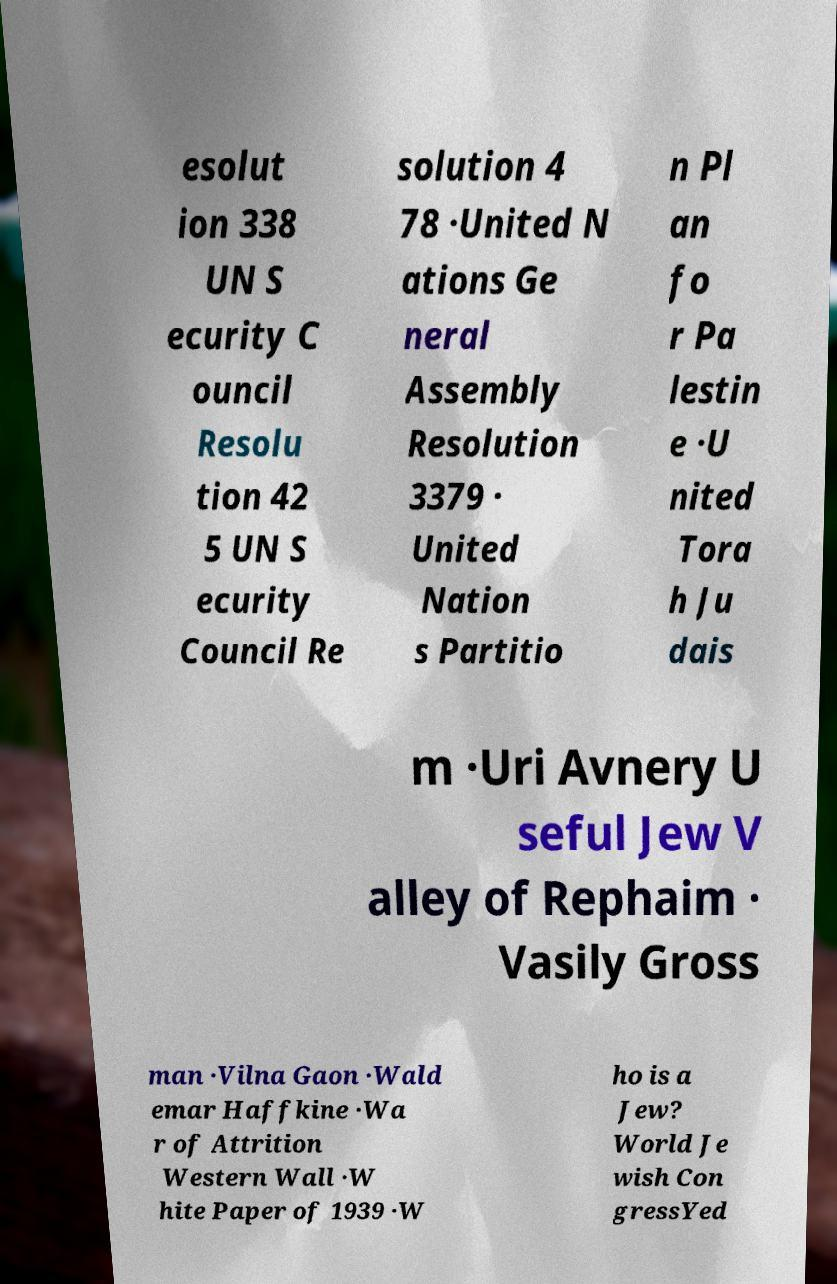Please read and relay the text visible in this image. What does it say? esolut ion 338 UN S ecurity C ouncil Resolu tion 42 5 UN S ecurity Council Re solution 4 78 ·United N ations Ge neral Assembly Resolution 3379 · United Nation s Partitio n Pl an fo r Pa lestin e ·U nited Tora h Ju dais m ·Uri Avnery U seful Jew V alley of Rephaim · Vasily Gross man ·Vilna Gaon ·Wald emar Haffkine ·Wa r of Attrition Western Wall ·W hite Paper of 1939 ·W ho is a Jew? World Je wish Con gressYed 